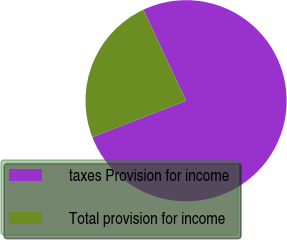<chart> <loc_0><loc_0><loc_500><loc_500><pie_chart><fcel>taxes Provision for income<fcel>Total provision for income<nl><fcel>76.13%<fcel>23.87%<nl></chart> 